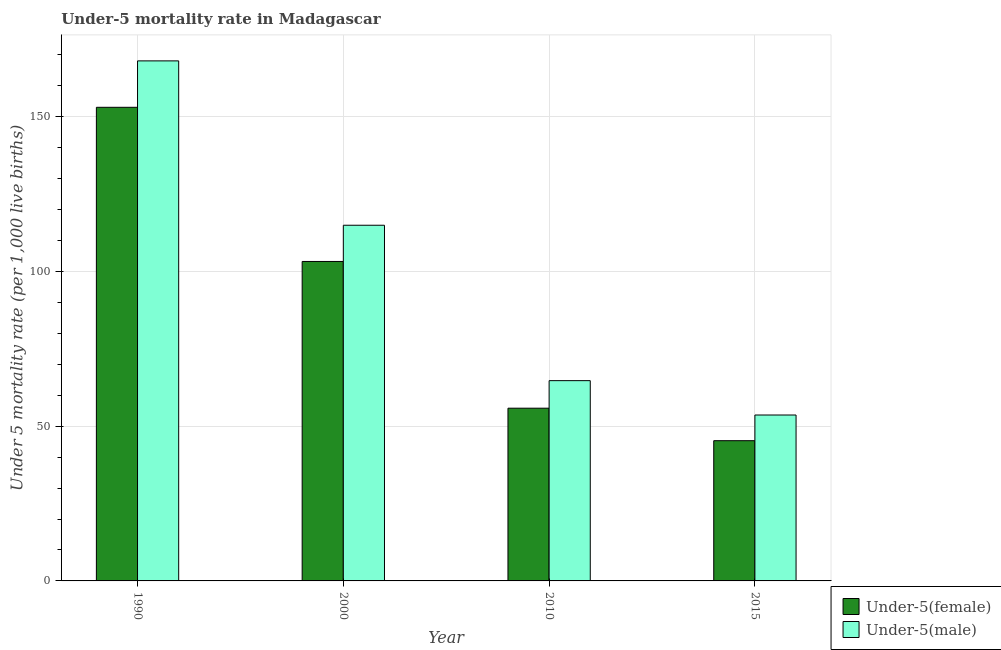How many groups of bars are there?
Ensure brevity in your answer.  4. Are the number of bars on each tick of the X-axis equal?
Your answer should be compact. Yes. How many bars are there on the 2nd tick from the left?
Ensure brevity in your answer.  2. How many bars are there on the 1st tick from the right?
Give a very brief answer. 2. In how many cases, is the number of bars for a given year not equal to the number of legend labels?
Offer a terse response. 0. What is the under-5 male mortality rate in 2010?
Offer a terse response. 64.7. Across all years, what is the maximum under-5 male mortality rate?
Your answer should be compact. 168. Across all years, what is the minimum under-5 female mortality rate?
Provide a short and direct response. 45.3. In which year was the under-5 female mortality rate minimum?
Your answer should be compact. 2015. What is the total under-5 male mortality rate in the graph?
Give a very brief answer. 401.2. What is the difference between the under-5 male mortality rate in 2000 and that in 2015?
Provide a succinct answer. 61.3. What is the difference between the under-5 female mortality rate in 2015 and the under-5 male mortality rate in 1990?
Provide a short and direct response. -107.7. What is the average under-5 male mortality rate per year?
Keep it short and to the point. 100.3. What is the ratio of the under-5 male mortality rate in 1990 to that in 2015?
Your response must be concise. 3.13. Is the difference between the under-5 female mortality rate in 1990 and 2000 greater than the difference between the under-5 male mortality rate in 1990 and 2000?
Keep it short and to the point. No. What is the difference between the highest and the second highest under-5 male mortality rate?
Give a very brief answer. 53.1. What is the difference between the highest and the lowest under-5 female mortality rate?
Make the answer very short. 107.7. In how many years, is the under-5 female mortality rate greater than the average under-5 female mortality rate taken over all years?
Provide a short and direct response. 2. Is the sum of the under-5 male mortality rate in 1990 and 2000 greater than the maximum under-5 female mortality rate across all years?
Ensure brevity in your answer.  Yes. What does the 2nd bar from the left in 1990 represents?
Your answer should be compact. Under-5(male). What does the 2nd bar from the right in 1990 represents?
Make the answer very short. Under-5(female). How many bars are there?
Your answer should be very brief. 8. Are all the bars in the graph horizontal?
Keep it short and to the point. No. Are the values on the major ticks of Y-axis written in scientific E-notation?
Offer a terse response. No. Where does the legend appear in the graph?
Make the answer very short. Bottom right. How many legend labels are there?
Give a very brief answer. 2. What is the title of the graph?
Offer a terse response. Under-5 mortality rate in Madagascar. Does "Passenger Transport Items" appear as one of the legend labels in the graph?
Provide a succinct answer. No. What is the label or title of the Y-axis?
Keep it short and to the point. Under 5 mortality rate (per 1,0 live births). What is the Under 5 mortality rate (per 1,000 live births) of Under-5(female) in 1990?
Provide a succinct answer. 153. What is the Under 5 mortality rate (per 1,000 live births) in Under-5(male) in 1990?
Provide a short and direct response. 168. What is the Under 5 mortality rate (per 1,000 live births) of Under-5(female) in 2000?
Make the answer very short. 103.2. What is the Under 5 mortality rate (per 1,000 live births) in Under-5(male) in 2000?
Your response must be concise. 114.9. What is the Under 5 mortality rate (per 1,000 live births) in Under-5(female) in 2010?
Your answer should be very brief. 55.8. What is the Under 5 mortality rate (per 1,000 live births) of Under-5(male) in 2010?
Your answer should be very brief. 64.7. What is the Under 5 mortality rate (per 1,000 live births) of Under-5(female) in 2015?
Provide a succinct answer. 45.3. What is the Under 5 mortality rate (per 1,000 live births) of Under-5(male) in 2015?
Provide a succinct answer. 53.6. Across all years, what is the maximum Under 5 mortality rate (per 1,000 live births) in Under-5(female)?
Your answer should be compact. 153. Across all years, what is the maximum Under 5 mortality rate (per 1,000 live births) of Under-5(male)?
Ensure brevity in your answer.  168. Across all years, what is the minimum Under 5 mortality rate (per 1,000 live births) of Under-5(female)?
Ensure brevity in your answer.  45.3. Across all years, what is the minimum Under 5 mortality rate (per 1,000 live births) of Under-5(male)?
Your response must be concise. 53.6. What is the total Under 5 mortality rate (per 1,000 live births) in Under-5(female) in the graph?
Keep it short and to the point. 357.3. What is the total Under 5 mortality rate (per 1,000 live births) of Under-5(male) in the graph?
Make the answer very short. 401.2. What is the difference between the Under 5 mortality rate (per 1,000 live births) in Under-5(female) in 1990 and that in 2000?
Offer a very short reply. 49.8. What is the difference between the Under 5 mortality rate (per 1,000 live births) of Under-5(male) in 1990 and that in 2000?
Ensure brevity in your answer.  53.1. What is the difference between the Under 5 mortality rate (per 1,000 live births) of Under-5(female) in 1990 and that in 2010?
Your answer should be compact. 97.2. What is the difference between the Under 5 mortality rate (per 1,000 live births) in Under-5(male) in 1990 and that in 2010?
Offer a very short reply. 103.3. What is the difference between the Under 5 mortality rate (per 1,000 live births) in Under-5(female) in 1990 and that in 2015?
Provide a succinct answer. 107.7. What is the difference between the Under 5 mortality rate (per 1,000 live births) in Under-5(male) in 1990 and that in 2015?
Provide a short and direct response. 114.4. What is the difference between the Under 5 mortality rate (per 1,000 live births) in Under-5(female) in 2000 and that in 2010?
Your response must be concise. 47.4. What is the difference between the Under 5 mortality rate (per 1,000 live births) of Under-5(male) in 2000 and that in 2010?
Offer a very short reply. 50.2. What is the difference between the Under 5 mortality rate (per 1,000 live births) of Under-5(female) in 2000 and that in 2015?
Provide a succinct answer. 57.9. What is the difference between the Under 5 mortality rate (per 1,000 live births) of Under-5(male) in 2000 and that in 2015?
Your answer should be compact. 61.3. What is the difference between the Under 5 mortality rate (per 1,000 live births) in Under-5(female) in 2010 and that in 2015?
Your answer should be very brief. 10.5. What is the difference between the Under 5 mortality rate (per 1,000 live births) of Under-5(female) in 1990 and the Under 5 mortality rate (per 1,000 live births) of Under-5(male) in 2000?
Ensure brevity in your answer.  38.1. What is the difference between the Under 5 mortality rate (per 1,000 live births) in Under-5(female) in 1990 and the Under 5 mortality rate (per 1,000 live births) in Under-5(male) in 2010?
Your answer should be compact. 88.3. What is the difference between the Under 5 mortality rate (per 1,000 live births) in Under-5(female) in 1990 and the Under 5 mortality rate (per 1,000 live births) in Under-5(male) in 2015?
Make the answer very short. 99.4. What is the difference between the Under 5 mortality rate (per 1,000 live births) in Under-5(female) in 2000 and the Under 5 mortality rate (per 1,000 live births) in Under-5(male) in 2010?
Provide a short and direct response. 38.5. What is the difference between the Under 5 mortality rate (per 1,000 live births) of Under-5(female) in 2000 and the Under 5 mortality rate (per 1,000 live births) of Under-5(male) in 2015?
Provide a succinct answer. 49.6. What is the average Under 5 mortality rate (per 1,000 live births) in Under-5(female) per year?
Ensure brevity in your answer.  89.33. What is the average Under 5 mortality rate (per 1,000 live births) in Under-5(male) per year?
Keep it short and to the point. 100.3. In the year 1990, what is the difference between the Under 5 mortality rate (per 1,000 live births) in Under-5(female) and Under 5 mortality rate (per 1,000 live births) in Under-5(male)?
Your answer should be compact. -15. In the year 2010, what is the difference between the Under 5 mortality rate (per 1,000 live births) in Under-5(female) and Under 5 mortality rate (per 1,000 live births) in Under-5(male)?
Your answer should be compact. -8.9. What is the ratio of the Under 5 mortality rate (per 1,000 live births) of Under-5(female) in 1990 to that in 2000?
Provide a short and direct response. 1.48. What is the ratio of the Under 5 mortality rate (per 1,000 live births) in Under-5(male) in 1990 to that in 2000?
Offer a terse response. 1.46. What is the ratio of the Under 5 mortality rate (per 1,000 live births) in Under-5(female) in 1990 to that in 2010?
Offer a terse response. 2.74. What is the ratio of the Under 5 mortality rate (per 1,000 live births) in Under-5(male) in 1990 to that in 2010?
Offer a very short reply. 2.6. What is the ratio of the Under 5 mortality rate (per 1,000 live births) of Under-5(female) in 1990 to that in 2015?
Make the answer very short. 3.38. What is the ratio of the Under 5 mortality rate (per 1,000 live births) in Under-5(male) in 1990 to that in 2015?
Ensure brevity in your answer.  3.13. What is the ratio of the Under 5 mortality rate (per 1,000 live births) in Under-5(female) in 2000 to that in 2010?
Your response must be concise. 1.85. What is the ratio of the Under 5 mortality rate (per 1,000 live births) of Under-5(male) in 2000 to that in 2010?
Your response must be concise. 1.78. What is the ratio of the Under 5 mortality rate (per 1,000 live births) of Under-5(female) in 2000 to that in 2015?
Keep it short and to the point. 2.28. What is the ratio of the Under 5 mortality rate (per 1,000 live births) in Under-5(male) in 2000 to that in 2015?
Your answer should be very brief. 2.14. What is the ratio of the Under 5 mortality rate (per 1,000 live births) in Under-5(female) in 2010 to that in 2015?
Give a very brief answer. 1.23. What is the ratio of the Under 5 mortality rate (per 1,000 live births) in Under-5(male) in 2010 to that in 2015?
Your answer should be very brief. 1.21. What is the difference between the highest and the second highest Under 5 mortality rate (per 1,000 live births) of Under-5(female)?
Offer a terse response. 49.8. What is the difference between the highest and the second highest Under 5 mortality rate (per 1,000 live births) of Under-5(male)?
Offer a terse response. 53.1. What is the difference between the highest and the lowest Under 5 mortality rate (per 1,000 live births) of Under-5(female)?
Make the answer very short. 107.7. What is the difference between the highest and the lowest Under 5 mortality rate (per 1,000 live births) in Under-5(male)?
Keep it short and to the point. 114.4. 